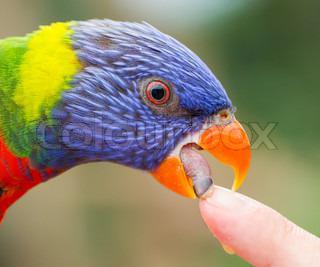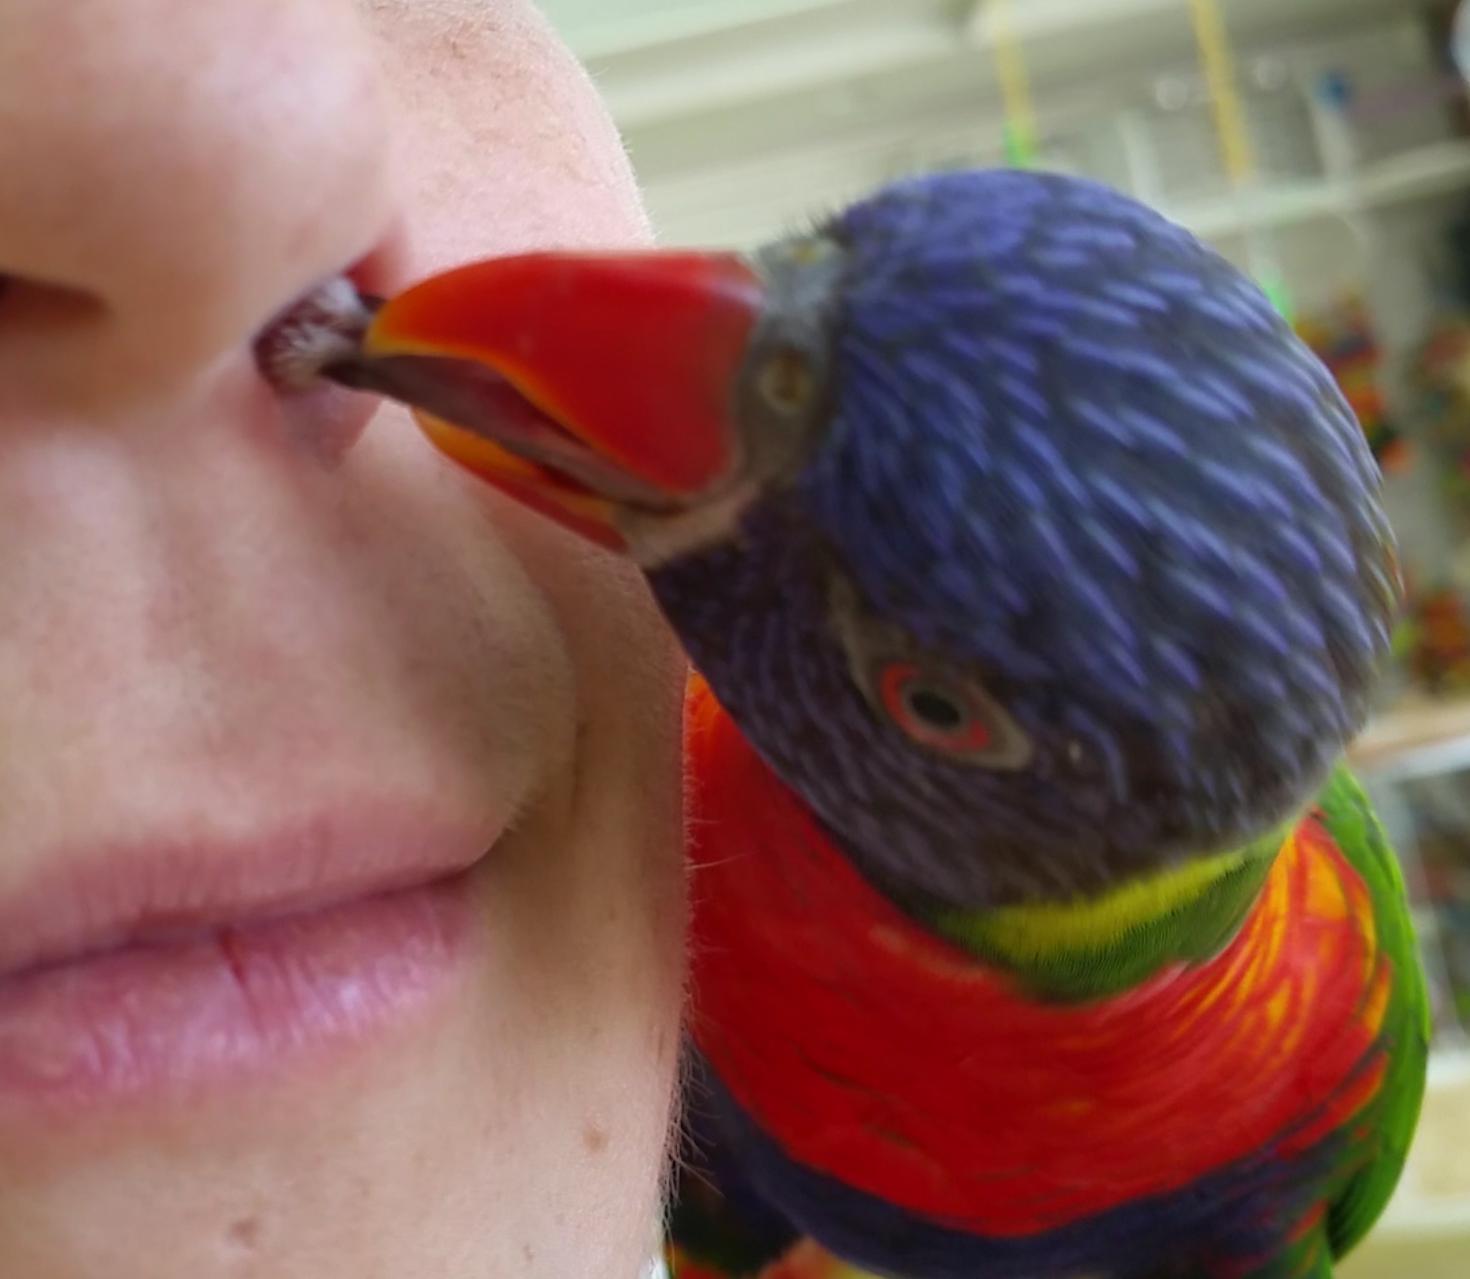The first image is the image on the left, the second image is the image on the right. Analyze the images presented: Is the assertion "There is at least two parrots in the right image." valid? Answer yes or no. No. The first image is the image on the left, the second image is the image on the right. Evaluate the accuracy of this statement regarding the images: "At least one image shows a colorful bird interacting with a human hand". Is it true? Answer yes or no. Yes. 